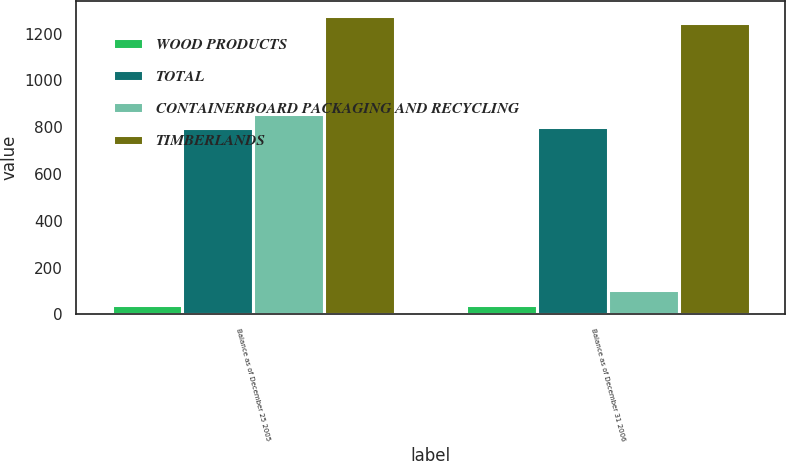Convert chart to OTSL. <chart><loc_0><loc_0><loc_500><loc_500><stacked_bar_chart><ecel><fcel>Balance as of December 25 2005<fcel>Balance as of December 31 2006<nl><fcel>WOOD PRODUCTS<fcel>40<fcel>40<nl><fcel>TOTAL<fcel>798<fcel>800<nl><fcel>CONTAINERBOARD PACKAGING AND RECYCLING<fcel>857<fcel>105<nl><fcel>TIMBERLANDS<fcel>1275<fcel>1244<nl></chart> 